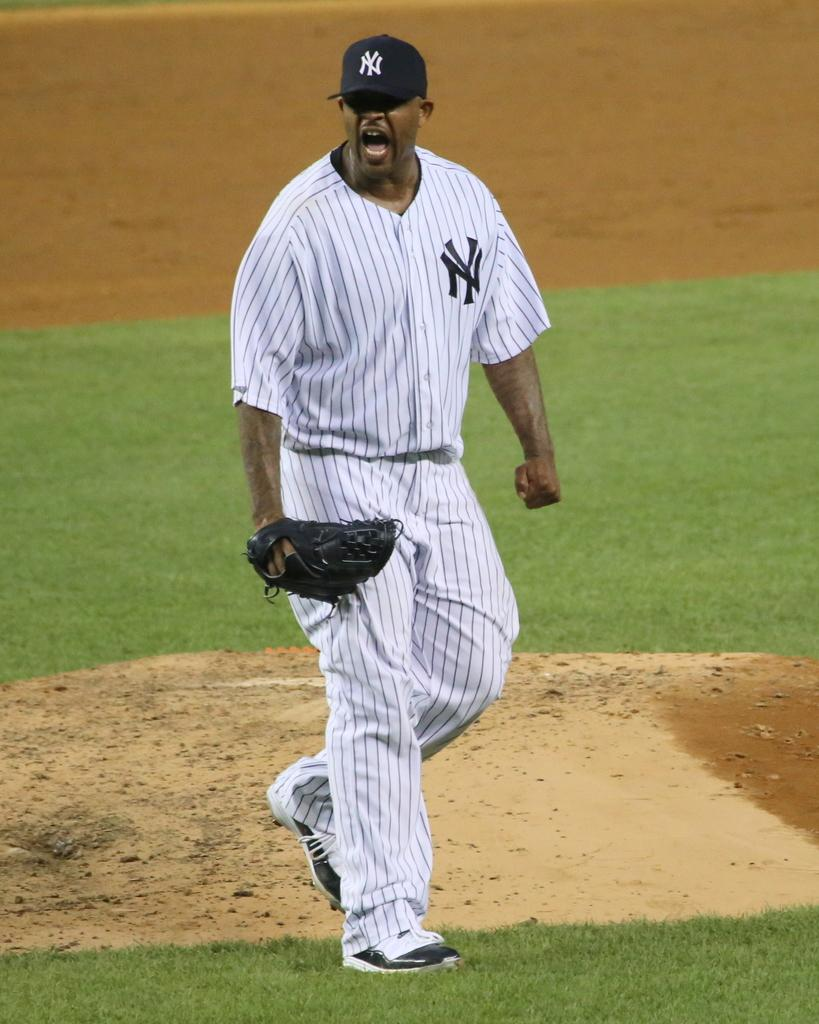<image>
Write a terse but informative summary of the picture. player wearing ny yankees uniform and cap walking and yelling on the field 